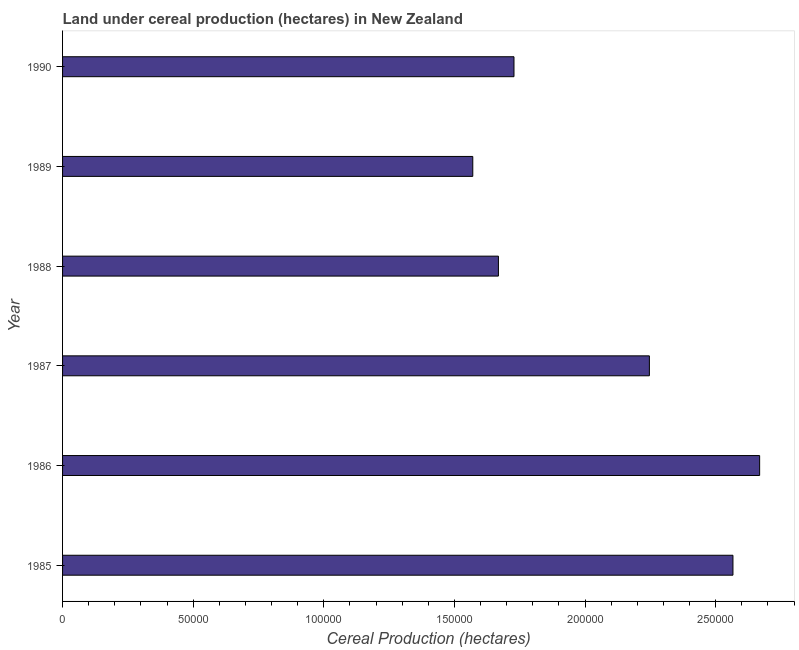What is the title of the graph?
Your answer should be compact. Land under cereal production (hectares) in New Zealand. What is the label or title of the X-axis?
Keep it short and to the point. Cereal Production (hectares). What is the land under cereal production in 1988?
Make the answer very short. 1.67e+05. Across all years, what is the maximum land under cereal production?
Offer a very short reply. 2.67e+05. Across all years, what is the minimum land under cereal production?
Offer a terse response. 1.57e+05. What is the sum of the land under cereal production?
Provide a short and direct response. 1.24e+06. What is the difference between the land under cereal production in 1987 and 1989?
Ensure brevity in your answer.  6.76e+04. What is the average land under cereal production per year?
Ensure brevity in your answer.  2.07e+05. What is the median land under cereal production?
Provide a short and direct response. 1.99e+05. In how many years, is the land under cereal production greater than 190000 hectares?
Keep it short and to the point. 3. Is the land under cereal production in 1985 less than that in 1988?
Provide a short and direct response. No. What is the difference between the highest and the second highest land under cereal production?
Provide a short and direct response. 1.02e+04. What is the difference between the highest and the lowest land under cereal production?
Make the answer very short. 1.10e+05. Are all the bars in the graph horizontal?
Provide a succinct answer. Yes. Are the values on the major ticks of X-axis written in scientific E-notation?
Provide a succinct answer. No. What is the Cereal Production (hectares) in 1985?
Provide a short and direct response. 2.57e+05. What is the Cereal Production (hectares) in 1986?
Offer a very short reply. 2.67e+05. What is the Cereal Production (hectares) in 1987?
Offer a terse response. 2.25e+05. What is the Cereal Production (hectares) in 1988?
Offer a very short reply. 1.67e+05. What is the Cereal Production (hectares) of 1989?
Your response must be concise. 1.57e+05. What is the Cereal Production (hectares) in 1990?
Provide a short and direct response. 1.73e+05. What is the difference between the Cereal Production (hectares) in 1985 and 1986?
Make the answer very short. -1.02e+04. What is the difference between the Cereal Production (hectares) in 1985 and 1987?
Your response must be concise. 3.20e+04. What is the difference between the Cereal Production (hectares) in 1985 and 1988?
Provide a succinct answer. 8.98e+04. What is the difference between the Cereal Production (hectares) in 1985 and 1989?
Offer a terse response. 9.96e+04. What is the difference between the Cereal Production (hectares) in 1985 and 1990?
Provide a succinct answer. 8.38e+04. What is the difference between the Cereal Production (hectares) in 1986 and 1987?
Ensure brevity in your answer.  4.22e+04. What is the difference between the Cereal Production (hectares) in 1986 and 1988?
Provide a short and direct response. 1.00e+05. What is the difference between the Cereal Production (hectares) in 1986 and 1989?
Give a very brief answer. 1.10e+05. What is the difference between the Cereal Production (hectares) in 1986 and 1990?
Your answer should be very brief. 9.40e+04. What is the difference between the Cereal Production (hectares) in 1987 and 1988?
Your answer should be very brief. 5.78e+04. What is the difference between the Cereal Production (hectares) in 1987 and 1989?
Provide a succinct answer. 6.76e+04. What is the difference between the Cereal Production (hectares) in 1987 and 1990?
Offer a very short reply. 5.18e+04. What is the difference between the Cereal Production (hectares) in 1988 and 1989?
Keep it short and to the point. 9813. What is the difference between the Cereal Production (hectares) in 1988 and 1990?
Your answer should be very brief. -5962. What is the difference between the Cereal Production (hectares) in 1989 and 1990?
Provide a short and direct response. -1.58e+04. What is the ratio of the Cereal Production (hectares) in 1985 to that in 1987?
Offer a terse response. 1.14. What is the ratio of the Cereal Production (hectares) in 1985 to that in 1988?
Make the answer very short. 1.54. What is the ratio of the Cereal Production (hectares) in 1985 to that in 1989?
Your response must be concise. 1.63. What is the ratio of the Cereal Production (hectares) in 1985 to that in 1990?
Provide a succinct answer. 1.49. What is the ratio of the Cereal Production (hectares) in 1986 to that in 1987?
Offer a very short reply. 1.19. What is the ratio of the Cereal Production (hectares) in 1986 to that in 1988?
Offer a terse response. 1.6. What is the ratio of the Cereal Production (hectares) in 1986 to that in 1989?
Offer a terse response. 1.7. What is the ratio of the Cereal Production (hectares) in 1986 to that in 1990?
Your response must be concise. 1.54. What is the ratio of the Cereal Production (hectares) in 1987 to that in 1988?
Ensure brevity in your answer.  1.35. What is the ratio of the Cereal Production (hectares) in 1987 to that in 1989?
Your answer should be very brief. 1.43. What is the ratio of the Cereal Production (hectares) in 1987 to that in 1990?
Give a very brief answer. 1.3. What is the ratio of the Cereal Production (hectares) in 1988 to that in 1989?
Give a very brief answer. 1.06. What is the ratio of the Cereal Production (hectares) in 1988 to that in 1990?
Your response must be concise. 0.96. What is the ratio of the Cereal Production (hectares) in 1989 to that in 1990?
Make the answer very short. 0.91. 